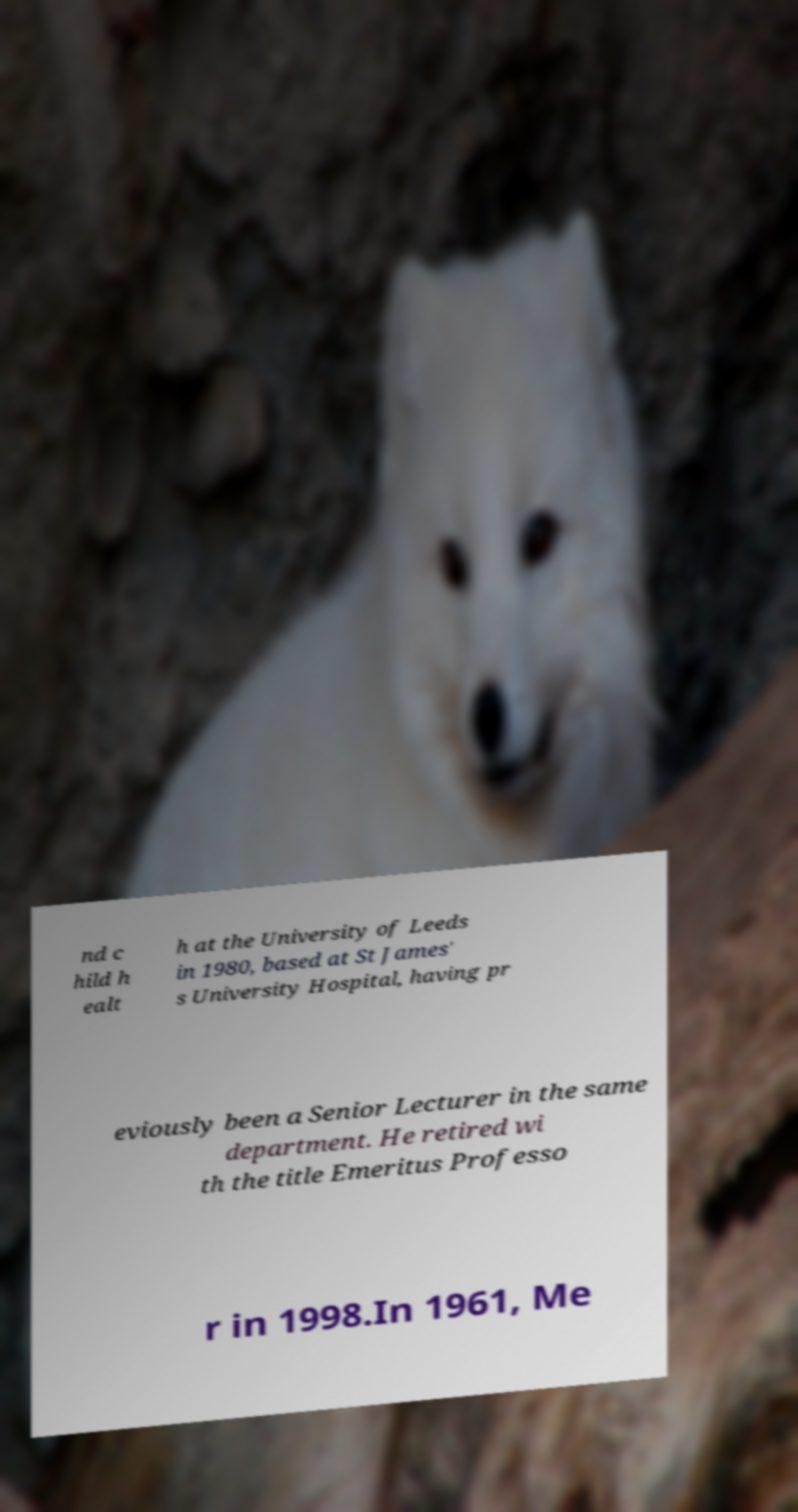Please identify and transcribe the text found in this image. nd c hild h ealt h at the University of Leeds in 1980, based at St James' s University Hospital, having pr eviously been a Senior Lecturer in the same department. He retired wi th the title Emeritus Professo r in 1998.In 1961, Me 